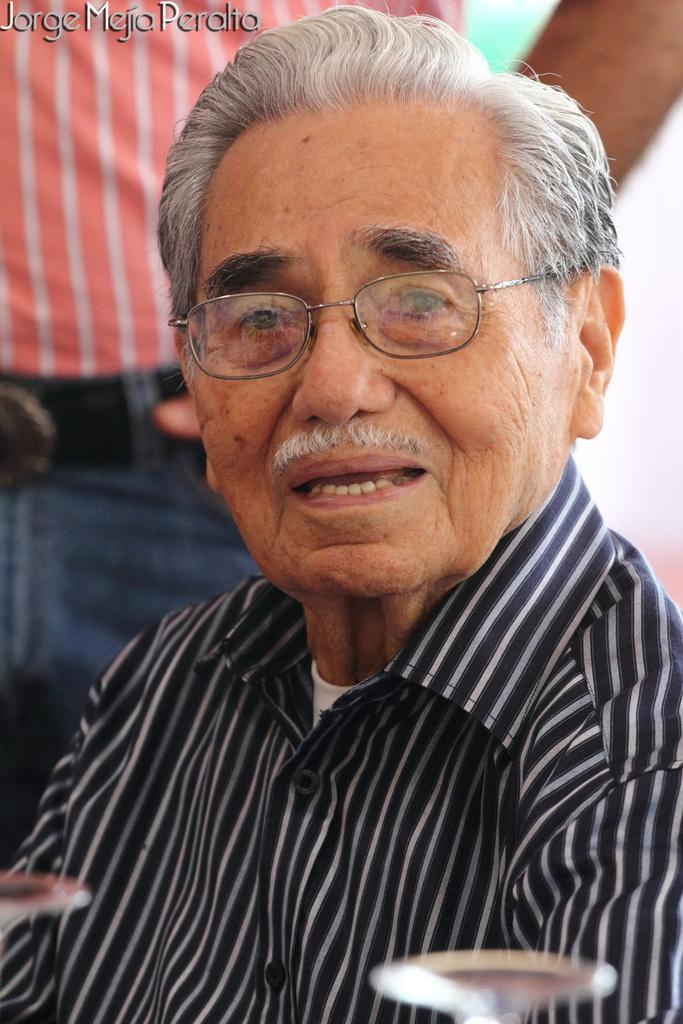What is the main subject of the image? The main subject of the image is an old man sitting. Can you describe the old man's clothing? The old man is wearing a black shirt with white color lines. Is there anyone else in the image besides the old man? Yes, there is a person standing behind the old man. What type of bird can be seen flying in the image? There is no bird present in the image; it features an old man sitting and another person standing behind him. What degree does the old man hold, as mentioned in the image? There is no mention of a degree held by the old man in the image or the provided facts. 